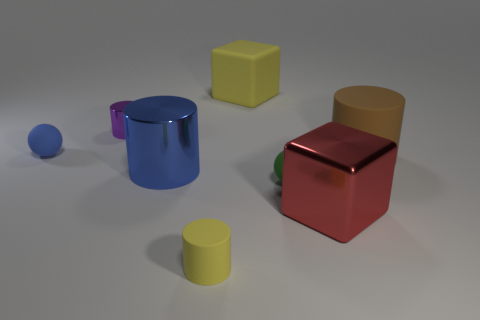How many big gray shiny cubes are there?
Make the answer very short. 0. What number of small rubber things are the same color as the small shiny cylinder?
Offer a very short reply. 0. There is a red metallic object on the right side of the large yellow matte block; is its shape the same as the big matte thing that is behind the large brown matte thing?
Offer a very short reply. Yes. There is a shiny object behind the tiny matte sphere behind the large cylinder behind the large blue metal cylinder; what is its color?
Your response must be concise. Purple. The big cylinder right of the red block is what color?
Your answer should be compact. Brown. There is a matte sphere that is the same size as the green matte object; what color is it?
Provide a succinct answer. Blue. Does the shiny block have the same size as the brown thing?
Keep it short and to the point. Yes. What number of small purple cylinders are left of the tiny purple object?
Provide a succinct answer. 0. How many objects are large matte things that are left of the red metal thing or big red metal things?
Keep it short and to the point. 2. Are there more yellow objects in front of the large brown object than small spheres that are behind the green rubber thing?
Your answer should be very brief. No. 